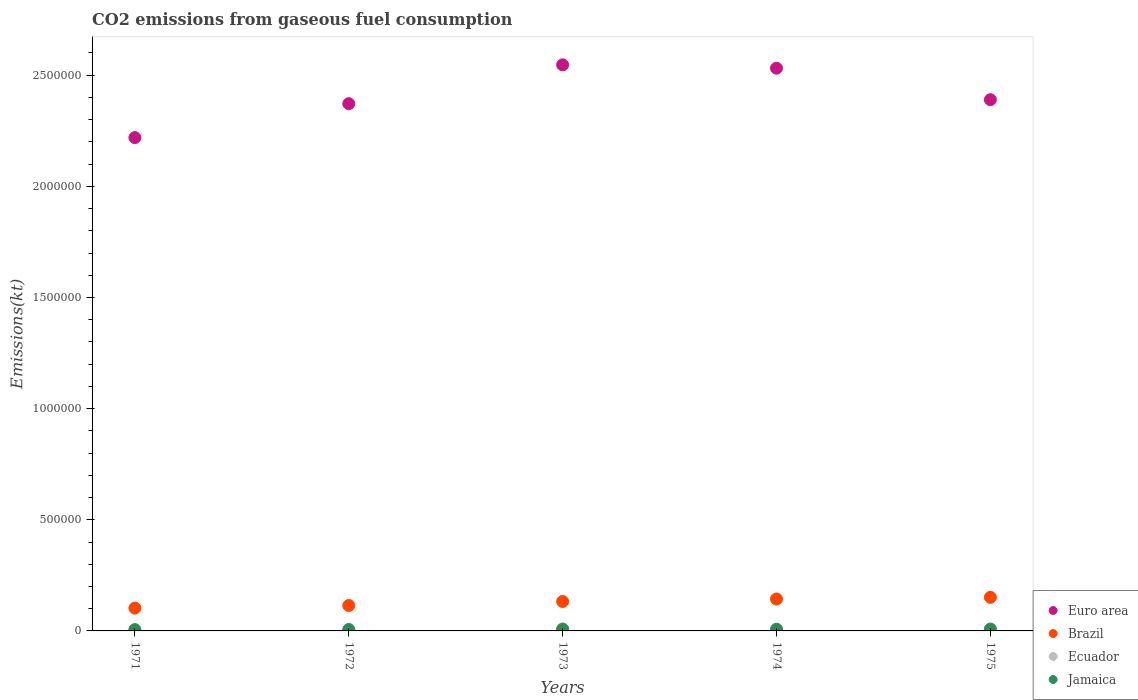Is the number of dotlines equal to the number of legend labels?
Your answer should be compact. Yes. What is the amount of CO2 emitted in Brazil in 1973?
Offer a terse response. 1.32e+05. Across all years, what is the maximum amount of CO2 emitted in Brazil?
Offer a terse response. 1.51e+05. Across all years, what is the minimum amount of CO2 emitted in Ecuador?
Provide a succinct answer. 4224.38. In which year was the amount of CO2 emitted in Ecuador maximum?
Make the answer very short. 1975. In which year was the amount of CO2 emitted in Ecuador minimum?
Make the answer very short. 1971. What is the total amount of CO2 emitted in Ecuador in the graph?
Your answer should be very brief. 2.75e+04. What is the difference between the amount of CO2 emitted in Brazil in 1973 and that in 1974?
Provide a short and direct response. -1.10e+04. What is the difference between the amount of CO2 emitted in Euro area in 1971 and the amount of CO2 emitted in Brazil in 1972?
Your answer should be compact. 2.11e+06. What is the average amount of CO2 emitted in Euro area per year?
Give a very brief answer. 2.41e+06. In the year 1973, what is the difference between the amount of CO2 emitted in Brazil and amount of CO2 emitted in Ecuador?
Offer a very short reply. 1.27e+05. In how many years, is the amount of CO2 emitted in Brazil greater than 800000 kt?
Your response must be concise. 0. What is the ratio of the amount of CO2 emitted in Brazil in 1974 to that in 1975?
Give a very brief answer. 0.95. Is the difference between the amount of CO2 emitted in Brazil in 1972 and 1973 greater than the difference between the amount of CO2 emitted in Ecuador in 1972 and 1973?
Your answer should be very brief. No. What is the difference between the highest and the second highest amount of CO2 emitted in Ecuador?
Your answer should be very brief. 1272.45. What is the difference between the highest and the lowest amount of CO2 emitted in Ecuador?
Your answer should be compact. 3138.95. In how many years, is the amount of CO2 emitted in Euro area greater than the average amount of CO2 emitted in Euro area taken over all years?
Offer a terse response. 2. Is the sum of the amount of CO2 emitted in Jamaica in 1971 and 1974 greater than the maximum amount of CO2 emitted in Ecuador across all years?
Offer a terse response. Yes. Does the amount of CO2 emitted in Jamaica monotonically increase over the years?
Provide a succinct answer. No. Is the amount of CO2 emitted in Euro area strictly less than the amount of CO2 emitted in Jamaica over the years?
Offer a terse response. No. What is the difference between two consecutive major ticks on the Y-axis?
Your answer should be very brief. 5.00e+05. Does the graph contain grids?
Make the answer very short. No. Where does the legend appear in the graph?
Your response must be concise. Bottom right. How many legend labels are there?
Ensure brevity in your answer.  4. How are the legend labels stacked?
Your answer should be very brief. Vertical. What is the title of the graph?
Give a very brief answer. CO2 emissions from gaseous fuel consumption. Does "Middle East & North Africa (developing only)" appear as one of the legend labels in the graph?
Keep it short and to the point. No. What is the label or title of the Y-axis?
Offer a very short reply. Emissions(kt). What is the Emissions(kt) in Euro area in 1971?
Your answer should be very brief. 2.22e+06. What is the Emissions(kt) of Brazil in 1971?
Your answer should be very brief. 1.03e+05. What is the Emissions(kt) in Ecuador in 1971?
Keep it short and to the point. 4224.38. What is the Emissions(kt) in Jamaica in 1971?
Keep it short and to the point. 5753.52. What is the Emissions(kt) of Euro area in 1972?
Provide a short and direct response. 2.37e+06. What is the Emissions(kt) in Brazil in 1972?
Offer a very short reply. 1.14e+05. What is the Emissions(kt) in Ecuador in 1972?
Ensure brevity in your answer.  4594.75. What is the Emissions(kt) in Jamaica in 1972?
Provide a succinct answer. 6288.9. What is the Emissions(kt) in Euro area in 1973?
Your response must be concise. 2.55e+06. What is the Emissions(kt) of Brazil in 1973?
Provide a succinct answer. 1.32e+05. What is the Emissions(kt) of Ecuador in 1973?
Keep it short and to the point. 5262.15. What is the Emissions(kt) of Jamaica in 1973?
Offer a terse response. 8298.42. What is the Emissions(kt) of Euro area in 1974?
Make the answer very short. 2.53e+06. What is the Emissions(kt) in Brazil in 1974?
Provide a succinct answer. 1.43e+05. What is the Emissions(kt) of Ecuador in 1974?
Make the answer very short. 6090.89. What is the Emissions(kt) in Jamaica in 1974?
Offer a terse response. 7601.69. What is the Emissions(kt) in Euro area in 1975?
Your answer should be very brief. 2.39e+06. What is the Emissions(kt) of Brazil in 1975?
Your response must be concise. 1.51e+05. What is the Emissions(kt) of Ecuador in 1975?
Ensure brevity in your answer.  7363.34. What is the Emissions(kt) of Jamaica in 1975?
Ensure brevity in your answer.  8188.41. Across all years, what is the maximum Emissions(kt) of Euro area?
Provide a short and direct response. 2.55e+06. Across all years, what is the maximum Emissions(kt) of Brazil?
Ensure brevity in your answer.  1.51e+05. Across all years, what is the maximum Emissions(kt) in Ecuador?
Your answer should be very brief. 7363.34. Across all years, what is the maximum Emissions(kt) in Jamaica?
Offer a terse response. 8298.42. Across all years, what is the minimum Emissions(kt) in Euro area?
Give a very brief answer. 2.22e+06. Across all years, what is the minimum Emissions(kt) of Brazil?
Make the answer very short. 1.03e+05. Across all years, what is the minimum Emissions(kt) of Ecuador?
Provide a succinct answer. 4224.38. Across all years, what is the minimum Emissions(kt) of Jamaica?
Offer a very short reply. 5753.52. What is the total Emissions(kt) in Euro area in the graph?
Give a very brief answer. 1.21e+07. What is the total Emissions(kt) of Brazil in the graph?
Your response must be concise. 6.44e+05. What is the total Emissions(kt) of Ecuador in the graph?
Provide a succinct answer. 2.75e+04. What is the total Emissions(kt) in Jamaica in the graph?
Your answer should be very brief. 3.61e+04. What is the difference between the Emissions(kt) of Euro area in 1971 and that in 1972?
Your response must be concise. -1.53e+05. What is the difference between the Emissions(kt) of Brazil in 1971 and that in 1972?
Your answer should be very brief. -1.17e+04. What is the difference between the Emissions(kt) of Ecuador in 1971 and that in 1972?
Provide a succinct answer. -370.37. What is the difference between the Emissions(kt) in Jamaica in 1971 and that in 1972?
Your answer should be very brief. -535.38. What is the difference between the Emissions(kt) of Euro area in 1971 and that in 1973?
Keep it short and to the point. -3.27e+05. What is the difference between the Emissions(kt) of Brazil in 1971 and that in 1973?
Ensure brevity in your answer.  -2.98e+04. What is the difference between the Emissions(kt) in Ecuador in 1971 and that in 1973?
Provide a short and direct response. -1037.76. What is the difference between the Emissions(kt) of Jamaica in 1971 and that in 1973?
Make the answer very short. -2544.9. What is the difference between the Emissions(kt) in Euro area in 1971 and that in 1974?
Give a very brief answer. -3.12e+05. What is the difference between the Emissions(kt) of Brazil in 1971 and that in 1974?
Keep it short and to the point. -4.08e+04. What is the difference between the Emissions(kt) in Ecuador in 1971 and that in 1974?
Your answer should be very brief. -1866.5. What is the difference between the Emissions(kt) of Jamaica in 1971 and that in 1974?
Keep it short and to the point. -1848.17. What is the difference between the Emissions(kt) in Euro area in 1971 and that in 1975?
Ensure brevity in your answer.  -1.70e+05. What is the difference between the Emissions(kt) in Brazil in 1971 and that in 1975?
Offer a very short reply. -4.85e+04. What is the difference between the Emissions(kt) in Ecuador in 1971 and that in 1975?
Keep it short and to the point. -3138.95. What is the difference between the Emissions(kt) of Jamaica in 1971 and that in 1975?
Ensure brevity in your answer.  -2434.89. What is the difference between the Emissions(kt) in Euro area in 1972 and that in 1973?
Offer a terse response. -1.75e+05. What is the difference between the Emissions(kt) of Brazil in 1972 and that in 1973?
Your answer should be compact. -1.81e+04. What is the difference between the Emissions(kt) of Ecuador in 1972 and that in 1973?
Make the answer very short. -667.39. What is the difference between the Emissions(kt) in Jamaica in 1972 and that in 1973?
Ensure brevity in your answer.  -2009.52. What is the difference between the Emissions(kt) in Euro area in 1972 and that in 1974?
Keep it short and to the point. -1.60e+05. What is the difference between the Emissions(kt) in Brazil in 1972 and that in 1974?
Ensure brevity in your answer.  -2.91e+04. What is the difference between the Emissions(kt) of Ecuador in 1972 and that in 1974?
Your answer should be very brief. -1496.14. What is the difference between the Emissions(kt) in Jamaica in 1972 and that in 1974?
Offer a terse response. -1312.79. What is the difference between the Emissions(kt) in Euro area in 1972 and that in 1975?
Provide a succinct answer. -1.79e+04. What is the difference between the Emissions(kt) in Brazil in 1972 and that in 1975?
Give a very brief answer. -3.68e+04. What is the difference between the Emissions(kt) of Ecuador in 1972 and that in 1975?
Your response must be concise. -2768.59. What is the difference between the Emissions(kt) in Jamaica in 1972 and that in 1975?
Offer a very short reply. -1899.51. What is the difference between the Emissions(kt) of Euro area in 1973 and that in 1974?
Ensure brevity in your answer.  1.52e+04. What is the difference between the Emissions(kt) of Brazil in 1973 and that in 1974?
Give a very brief answer. -1.10e+04. What is the difference between the Emissions(kt) in Ecuador in 1973 and that in 1974?
Provide a short and direct response. -828.74. What is the difference between the Emissions(kt) in Jamaica in 1973 and that in 1974?
Keep it short and to the point. 696.73. What is the difference between the Emissions(kt) of Euro area in 1973 and that in 1975?
Give a very brief answer. 1.57e+05. What is the difference between the Emissions(kt) of Brazil in 1973 and that in 1975?
Provide a short and direct response. -1.87e+04. What is the difference between the Emissions(kt) of Ecuador in 1973 and that in 1975?
Offer a terse response. -2101.19. What is the difference between the Emissions(kt) of Jamaica in 1973 and that in 1975?
Your answer should be compact. 110.01. What is the difference between the Emissions(kt) in Euro area in 1974 and that in 1975?
Your answer should be very brief. 1.42e+05. What is the difference between the Emissions(kt) in Brazil in 1974 and that in 1975?
Provide a succinct answer. -7708.03. What is the difference between the Emissions(kt) of Ecuador in 1974 and that in 1975?
Give a very brief answer. -1272.45. What is the difference between the Emissions(kt) of Jamaica in 1974 and that in 1975?
Give a very brief answer. -586.72. What is the difference between the Emissions(kt) of Euro area in 1971 and the Emissions(kt) of Brazil in 1972?
Your answer should be very brief. 2.11e+06. What is the difference between the Emissions(kt) in Euro area in 1971 and the Emissions(kt) in Ecuador in 1972?
Offer a terse response. 2.21e+06. What is the difference between the Emissions(kt) of Euro area in 1971 and the Emissions(kt) of Jamaica in 1972?
Offer a terse response. 2.21e+06. What is the difference between the Emissions(kt) of Brazil in 1971 and the Emissions(kt) of Ecuador in 1972?
Your response must be concise. 9.80e+04. What is the difference between the Emissions(kt) in Brazil in 1971 and the Emissions(kt) in Jamaica in 1972?
Keep it short and to the point. 9.63e+04. What is the difference between the Emissions(kt) in Ecuador in 1971 and the Emissions(kt) in Jamaica in 1972?
Provide a succinct answer. -2064.52. What is the difference between the Emissions(kt) in Euro area in 1971 and the Emissions(kt) in Brazil in 1973?
Your answer should be very brief. 2.09e+06. What is the difference between the Emissions(kt) of Euro area in 1971 and the Emissions(kt) of Ecuador in 1973?
Keep it short and to the point. 2.21e+06. What is the difference between the Emissions(kt) of Euro area in 1971 and the Emissions(kt) of Jamaica in 1973?
Your answer should be compact. 2.21e+06. What is the difference between the Emissions(kt) in Brazil in 1971 and the Emissions(kt) in Ecuador in 1973?
Make the answer very short. 9.74e+04. What is the difference between the Emissions(kt) in Brazil in 1971 and the Emissions(kt) in Jamaica in 1973?
Provide a succinct answer. 9.43e+04. What is the difference between the Emissions(kt) of Ecuador in 1971 and the Emissions(kt) of Jamaica in 1973?
Provide a succinct answer. -4074.04. What is the difference between the Emissions(kt) in Euro area in 1971 and the Emissions(kt) in Brazil in 1974?
Your answer should be compact. 2.08e+06. What is the difference between the Emissions(kt) of Euro area in 1971 and the Emissions(kt) of Ecuador in 1974?
Make the answer very short. 2.21e+06. What is the difference between the Emissions(kt) of Euro area in 1971 and the Emissions(kt) of Jamaica in 1974?
Your answer should be compact. 2.21e+06. What is the difference between the Emissions(kt) of Brazil in 1971 and the Emissions(kt) of Ecuador in 1974?
Provide a succinct answer. 9.65e+04. What is the difference between the Emissions(kt) in Brazil in 1971 and the Emissions(kt) in Jamaica in 1974?
Your response must be concise. 9.50e+04. What is the difference between the Emissions(kt) in Ecuador in 1971 and the Emissions(kt) in Jamaica in 1974?
Offer a terse response. -3377.31. What is the difference between the Emissions(kt) of Euro area in 1971 and the Emissions(kt) of Brazil in 1975?
Provide a succinct answer. 2.07e+06. What is the difference between the Emissions(kt) in Euro area in 1971 and the Emissions(kt) in Ecuador in 1975?
Give a very brief answer. 2.21e+06. What is the difference between the Emissions(kt) in Euro area in 1971 and the Emissions(kt) in Jamaica in 1975?
Keep it short and to the point. 2.21e+06. What is the difference between the Emissions(kt) in Brazil in 1971 and the Emissions(kt) in Ecuador in 1975?
Your answer should be compact. 9.53e+04. What is the difference between the Emissions(kt) of Brazil in 1971 and the Emissions(kt) of Jamaica in 1975?
Provide a succinct answer. 9.44e+04. What is the difference between the Emissions(kt) in Ecuador in 1971 and the Emissions(kt) in Jamaica in 1975?
Make the answer very short. -3964.03. What is the difference between the Emissions(kt) in Euro area in 1972 and the Emissions(kt) in Brazil in 1973?
Your answer should be compact. 2.24e+06. What is the difference between the Emissions(kt) of Euro area in 1972 and the Emissions(kt) of Ecuador in 1973?
Keep it short and to the point. 2.37e+06. What is the difference between the Emissions(kt) in Euro area in 1972 and the Emissions(kt) in Jamaica in 1973?
Keep it short and to the point. 2.36e+06. What is the difference between the Emissions(kt) of Brazil in 1972 and the Emissions(kt) of Ecuador in 1973?
Make the answer very short. 1.09e+05. What is the difference between the Emissions(kt) in Brazil in 1972 and the Emissions(kt) in Jamaica in 1973?
Provide a short and direct response. 1.06e+05. What is the difference between the Emissions(kt) in Ecuador in 1972 and the Emissions(kt) in Jamaica in 1973?
Your response must be concise. -3703.67. What is the difference between the Emissions(kt) of Euro area in 1972 and the Emissions(kt) of Brazil in 1974?
Offer a very short reply. 2.23e+06. What is the difference between the Emissions(kt) of Euro area in 1972 and the Emissions(kt) of Ecuador in 1974?
Your answer should be compact. 2.37e+06. What is the difference between the Emissions(kt) of Euro area in 1972 and the Emissions(kt) of Jamaica in 1974?
Offer a terse response. 2.36e+06. What is the difference between the Emissions(kt) of Brazil in 1972 and the Emissions(kt) of Ecuador in 1974?
Make the answer very short. 1.08e+05. What is the difference between the Emissions(kt) in Brazil in 1972 and the Emissions(kt) in Jamaica in 1974?
Ensure brevity in your answer.  1.07e+05. What is the difference between the Emissions(kt) in Ecuador in 1972 and the Emissions(kt) in Jamaica in 1974?
Provide a succinct answer. -3006.94. What is the difference between the Emissions(kt) in Euro area in 1972 and the Emissions(kt) in Brazil in 1975?
Make the answer very short. 2.22e+06. What is the difference between the Emissions(kt) in Euro area in 1972 and the Emissions(kt) in Ecuador in 1975?
Offer a terse response. 2.36e+06. What is the difference between the Emissions(kt) in Euro area in 1972 and the Emissions(kt) in Jamaica in 1975?
Ensure brevity in your answer.  2.36e+06. What is the difference between the Emissions(kt) in Brazil in 1972 and the Emissions(kt) in Ecuador in 1975?
Ensure brevity in your answer.  1.07e+05. What is the difference between the Emissions(kt) of Brazil in 1972 and the Emissions(kt) of Jamaica in 1975?
Ensure brevity in your answer.  1.06e+05. What is the difference between the Emissions(kt) in Ecuador in 1972 and the Emissions(kt) in Jamaica in 1975?
Ensure brevity in your answer.  -3593.66. What is the difference between the Emissions(kt) in Euro area in 1973 and the Emissions(kt) in Brazil in 1974?
Offer a terse response. 2.40e+06. What is the difference between the Emissions(kt) of Euro area in 1973 and the Emissions(kt) of Ecuador in 1974?
Your answer should be very brief. 2.54e+06. What is the difference between the Emissions(kt) of Euro area in 1973 and the Emissions(kt) of Jamaica in 1974?
Provide a short and direct response. 2.54e+06. What is the difference between the Emissions(kt) of Brazil in 1973 and the Emissions(kt) of Ecuador in 1974?
Your answer should be compact. 1.26e+05. What is the difference between the Emissions(kt) in Brazil in 1973 and the Emissions(kt) in Jamaica in 1974?
Your answer should be very brief. 1.25e+05. What is the difference between the Emissions(kt) of Ecuador in 1973 and the Emissions(kt) of Jamaica in 1974?
Your answer should be compact. -2339.55. What is the difference between the Emissions(kt) in Euro area in 1973 and the Emissions(kt) in Brazil in 1975?
Provide a succinct answer. 2.40e+06. What is the difference between the Emissions(kt) in Euro area in 1973 and the Emissions(kt) in Ecuador in 1975?
Offer a terse response. 2.54e+06. What is the difference between the Emissions(kt) in Euro area in 1973 and the Emissions(kt) in Jamaica in 1975?
Provide a succinct answer. 2.54e+06. What is the difference between the Emissions(kt) of Brazil in 1973 and the Emissions(kt) of Ecuador in 1975?
Your answer should be compact. 1.25e+05. What is the difference between the Emissions(kt) in Brazil in 1973 and the Emissions(kt) in Jamaica in 1975?
Keep it short and to the point. 1.24e+05. What is the difference between the Emissions(kt) of Ecuador in 1973 and the Emissions(kt) of Jamaica in 1975?
Your answer should be very brief. -2926.27. What is the difference between the Emissions(kt) in Euro area in 1974 and the Emissions(kt) in Brazil in 1975?
Give a very brief answer. 2.38e+06. What is the difference between the Emissions(kt) in Euro area in 1974 and the Emissions(kt) in Ecuador in 1975?
Your response must be concise. 2.52e+06. What is the difference between the Emissions(kt) of Euro area in 1974 and the Emissions(kt) of Jamaica in 1975?
Provide a succinct answer. 2.52e+06. What is the difference between the Emissions(kt) in Brazil in 1974 and the Emissions(kt) in Ecuador in 1975?
Keep it short and to the point. 1.36e+05. What is the difference between the Emissions(kt) of Brazil in 1974 and the Emissions(kt) of Jamaica in 1975?
Ensure brevity in your answer.  1.35e+05. What is the difference between the Emissions(kt) of Ecuador in 1974 and the Emissions(kt) of Jamaica in 1975?
Ensure brevity in your answer.  -2097.52. What is the average Emissions(kt) in Euro area per year?
Keep it short and to the point. 2.41e+06. What is the average Emissions(kt) in Brazil per year?
Ensure brevity in your answer.  1.29e+05. What is the average Emissions(kt) in Ecuador per year?
Make the answer very short. 5507.1. What is the average Emissions(kt) of Jamaica per year?
Your answer should be very brief. 7226.19. In the year 1971, what is the difference between the Emissions(kt) in Euro area and Emissions(kt) in Brazil?
Make the answer very short. 2.12e+06. In the year 1971, what is the difference between the Emissions(kt) in Euro area and Emissions(kt) in Ecuador?
Give a very brief answer. 2.22e+06. In the year 1971, what is the difference between the Emissions(kt) of Euro area and Emissions(kt) of Jamaica?
Offer a very short reply. 2.21e+06. In the year 1971, what is the difference between the Emissions(kt) in Brazil and Emissions(kt) in Ecuador?
Provide a short and direct response. 9.84e+04. In the year 1971, what is the difference between the Emissions(kt) of Brazil and Emissions(kt) of Jamaica?
Provide a succinct answer. 9.69e+04. In the year 1971, what is the difference between the Emissions(kt) in Ecuador and Emissions(kt) in Jamaica?
Provide a short and direct response. -1529.14. In the year 1972, what is the difference between the Emissions(kt) of Euro area and Emissions(kt) of Brazil?
Offer a terse response. 2.26e+06. In the year 1972, what is the difference between the Emissions(kt) in Euro area and Emissions(kt) in Ecuador?
Ensure brevity in your answer.  2.37e+06. In the year 1972, what is the difference between the Emissions(kt) of Euro area and Emissions(kt) of Jamaica?
Provide a succinct answer. 2.37e+06. In the year 1972, what is the difference between the Emissions(kt) of Brazil and Emissions(kt) of Ecuador?
Ensure brevity in your answer.  1.10e+05. In the year 1972, what is the difference between the Emissions(kt) of Brazil and Emissions(kt) of Jamaica?
Your response must be concise. 1.08e+05. In the year 1972, what is the difference between the Emissions(kt) in Ecuador and Emissions(kt) in Jamaica?
Your response must be concise. -1694.15. In the year 1973, what is the difference between the Emissions(kt) of Euro area and Emissions(kt) of Brazil?
Make the answer very short. 2.41e+06. In the year 1973, what is the difference between the Emissions(kt) in Euro area and Emissions(kt) in Ecuador?
Keep it short and to the point. 2.54e+06. In the year 1973, what is the difference between the Emissions(kt) in Euro area and Emissions(kt) in Jamaica?
Give a very brief answer. 2.54e+06. In the year 1973, what is the difference between the Emissions(kt) of Brazil and Emissions(kt) of Ecuador?
Give a very brief answer. 1.27e+05. In the year 1973, what is the difference between the Emissions(kt) in Brazil and Emissions(kt) in Jamaica?
Keep it short and to the point. 1.24e+05. In the year 1973, what is the difference between the Emissions(kt) of Ecuador and Emissions(kt) of Jamaica?
Make the answer very short. -3036.28. In the year 1974, what is the difference between the Emissions(kt) of Euro area and Emissions(kt) of Brazil?
Ensure brevity in your answer.  2.39e+06. In the year 1974, what is the difference between the Emissions(kt) in Euro area and Emissions(kt) in Ecuador?
Keep it short and to the point. 2.53e+06. In the year 1974, what is the difference between the Emissions(kt) of Euro area and Emissions(kt) of Jamaica?
Your answer should be compact. 2.52e+06. In the year 1974, what is the difference between the Emissions(kt) in Brazil and Emissions(kt) in Ecuador?
Your answer should be compact. 1.37e+05. In the year 1974, what is the difference between the Emissions(kt) in Brazil and Emissions(kt) in Jamaica?
Give a very brief answer. 1.36e+05. In the year 1974, what is the difference between the Emissions(kt) in Ecuador and Emissions(kt) in Jamaica?
Your response must be concise. -1510.8. In the year 1975, what is the difference between the Emissions(kt) in Euro area and Emissions(kt) in Brazil?
Give a very brief answer. 2.24e+06. In the year 1975, what is the difference between the Emissions(kt) in Euro area and Emissions(kt) in Ecuador?
Your answer should be compact. 2.38e+06. In the year 1975, what is the difference between the Emissions(kt) of Euro area and Emissions(kt) of Jamaica?
Make the answer very short. 2.38e+06. In the year 1975, what is the difference between the Emissions(kt) in Brazil and Emissions(kt) in Ecuador?
Make the answer very short. 1.44e+05. In the year 1975, what is the difference between the Emissions(kt) of Brazil and Emissions(kt) of Jamaica?
Provide a short and direct response. 1.43e+05. In the year 1975, what is the difference between the Emissions(kt) of Ecuador and Emissions(kt) of Jamaica?
Ensure brevity in your answer.  -825.08. What is the ratio of the Emissions(kt) in Euro area in 1971 to that in 1972?
Give a very brief answer. 0.94. What is the ratio of the Emissions(kt) in Brazil in 1971 to that in 1972?
Provide a short and direct response. 0.9. What is the ratio of the Emissions(kt) of Ecuador in 1971 to that in 1972?
Provide a short and direct response. 0.92. What is the ratio of the Emissions(kt) in Jamaica in 1971 to that in 1972?
Keep it short and to the point. 0.91. What is the ratio of the Emissions(kt) of Euro area in 1971 to that in 1973?
Make the answer very short. 0.87. What is the ratio of the Emissions(kt) in Brazil in 1971 to that in 1973?
Give a very brief answer. 0.77. What is the ratio of the Emissions(kt) in Ecuador in 1971 to that in 1973?
Your answer should be compact. 0.8. What is the ratio of the Emissions(kt) of Jamaica in 1971 to that in 1973?
Provide a short and direct response. 0.69. What is the ratio of the Emissions(kt) in Euro area in 1971 to that in 1974?
Ensure brevity in your answer.  0.88. What is the ratio of the Emissions(kt) in Brazil in 1971 to that in 1974?
Provide a short and direct response. 0.72. What is the ratio of the Emissions(kt) of Ecuador in 1971 to that in 1974?
Provide a succinct answer. 0.69. What is the ratio of the Emissions(kt) in Jamaica in 1971 to that in 1974?
Make the answer very short. 0.76. What is the ratio of the Emissions(kt) in Euro area in 1971 to that in 1975?
Provide a succinct answer. 0.93. What is the ratio of the Emissions(kt) in Brazil in 1971 to that in 1975?
Your answer should be compact. 0.68. What is the ratio of the Emissions(kt) of Ecuador in 1971 to that in 1975?
Keep it short and to the point. 0.57. What is the ratio of the Emissions(kt) of Jamaica in 1971 to that in 1975?
Keep it short and to the point. 0.7. What is the ratio of the Emissions(kt) of Euro area in 1972 to that in 1973?
Provide a succinct answer. 0.93. What is the ratio of the Emissions(kt) in Brazil in 1972 to that in 1973?
Your answer should be compact. 0.86. What is the ratio of the Emissions(kt) of Ecuador in 1972 to that in 1973?
Your response must be concise. 0.87. What is the ratio of the Emissions(kt) of Jamaica in 1972 to that in 1973?
Your response must be concise. 0.76. What is the ratio of the Emissions(kt) of Euro area in 1972 to that in 1974?
Make the answer very short. 0.94. What is the ratio of the Emissions(kt) in Brazil in 1972 to that in 1974?
Make the answer very short. 0.8. What is the ratio of the Emissions(kt) of Ecuador in 1972 to that in 1974?
Ensure brevity in your answer.  0.75. What is the ratio of the Emissions(kt) of Jamaica in 1972 to that in 1974?
Your answer should be compact. 0.83. What is the ratio of the Emissions(kt) of Brazil in 1972 to that in 1975?
Give a very brief answer. 0.76. What is the ratio of the Emissions(kt) in Ecuador in 1972 to that in 1975?
Keep it short and to the point. 0.62. What is the ratio of the Emissions(kt) of Jamaica in 1972 to that in 1975?
Provide a succinct answer. 0.77. What is the ratio of the Emissions(kt) in Euro area in 1973 to that in 1974?
Give a very brief answer. 1.01. What is the ratio of the Emissions(kt) of Brazil in 1973 to that in 1974?
Make the answer very short. 0.92. What is the ratio of the Emissions(kt) in Ecuador in 1973 to that in 1974?
Provide a short and direct response. 0.86. What is the ratio of the Emissions(kt) in Jamaica in 1973 to that in 1974?
Your response must be concise. 1.09. What is the ratio of the Emissions(kt) of Euro area in 1973 to that in 1975?
Keep it short and to the point. 1.07. What is the ratio of the Emissions(kt) in Brazil in 1973 to that in 1975?
Give a very brief answer. 0.88. What is the ratio of the Emissions(kt) in Ecuador in 1973 to that in 1975?
Give a very brief answer. 0.71. What is the ratio of the Emissions(kt) of Jamaica in 1973 to that in 1975?
Ensure brevity in your answer.  1.01. What is the ratio of the Emissions(kt) of Euro area in 1974 to that in 1975?
Offer a very short reply. 1.06. What is the ratio of the Emissions(kt) in Brazil in 1974 to that in 1975?
Make the answer very short. 0.95. What is the ratio of the Emissions(kt) of Ecuador in 1974 to that in 1975?
Your answer should be very brief. 0.83. What is the ratio of the Emissions(kt) of Jamaica in 1974 to that in 1975?
Keep it short and to the point. 0.93. What is the difference between the highest and the second highest Emissions(kt) in Euro area?
Keep it short and to the point. 1.52e+04. What is the difference between the highest and the second highest Emissions(kt) of Brazil?
Provide a succinct answer. 7708.03. What is the difference between the highest and the second highest Emissions(kt) in Ecuador?
Give a very brief answer. 1272.45. What is the difference between the highest and the second highest Emissions(kt) in Jamaica?
Your response must be concise. 110.01. What is the difference between the highest and the lowest Emissions(kt) in Euro area?
Give a very brief answer. 3.27e+05. What is the difference between the highest and the lowest Emissions(kt) of Brazil?
Keep it short and to the point. 4.85e+04. What is the difference between the highest and the lowest Emissions(kt) in Ecuador?
Your answer should be very brief. 3138.95. What is the difference between the highest and the lowest Emissions(kt) in Jamaica?
Your answer should be very brief. 2544.9. 